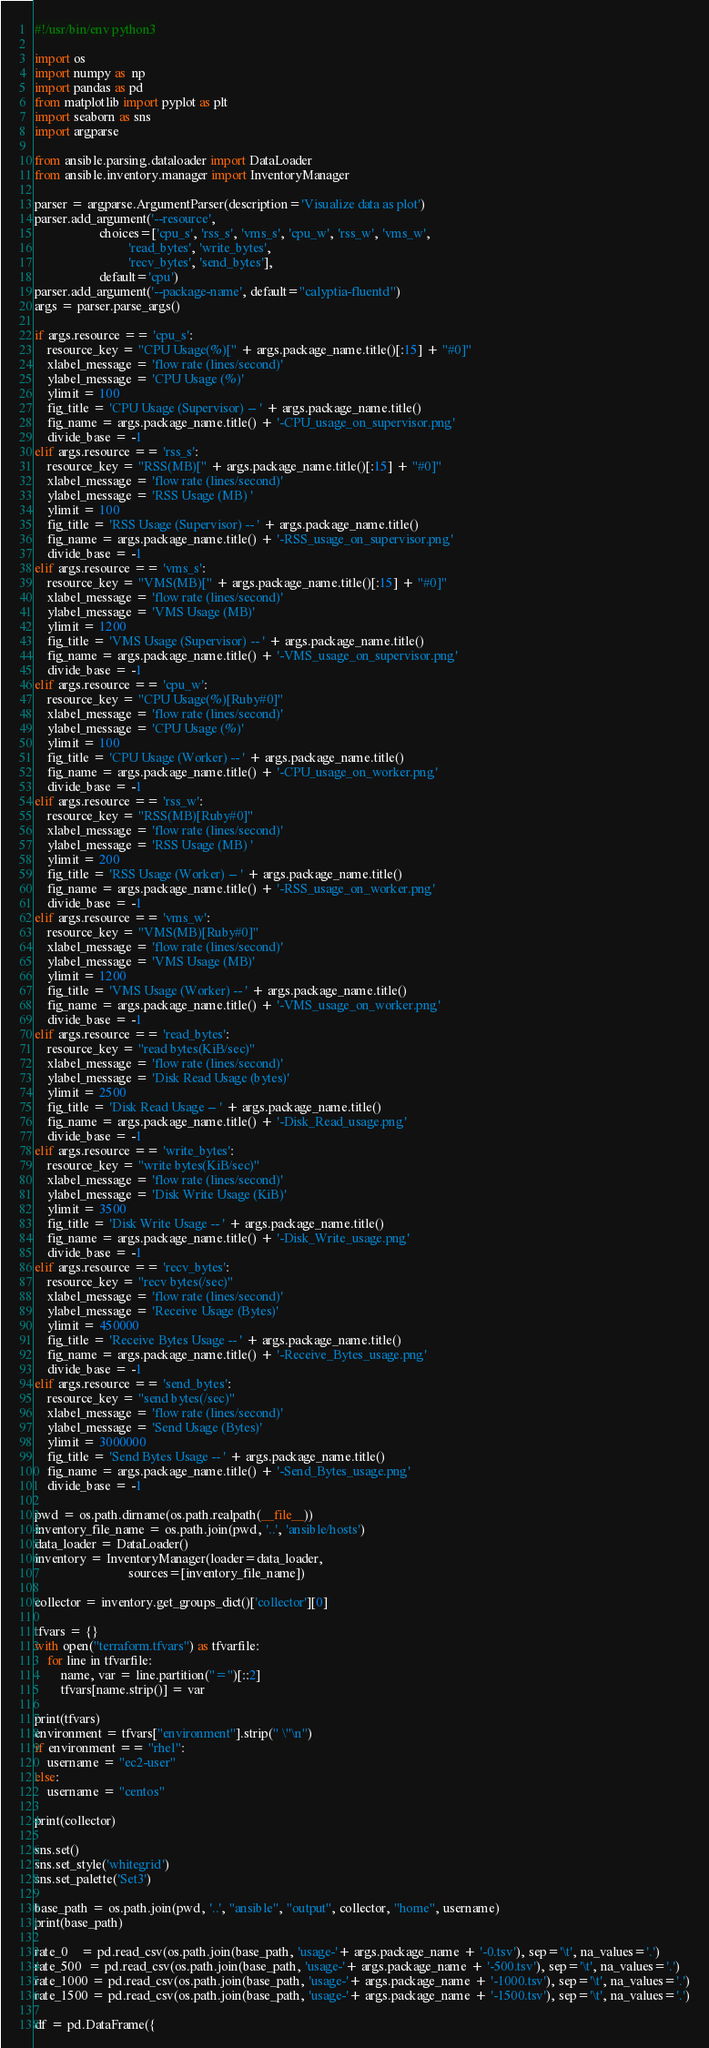<code> <loc_0><loc_0><loc_500><loc_500><_Python_>#!/usr/bin/env python3

import os
import numpy as  np
import pandas as pd
from matplotlib import pyplot as plt
import seaborn as sns
import argparse

from ansible.parsing.dataloader import DataLoader
from ansible.inventory.manager import InventoryManager

parser = argparse.ArgumentParser(description='Visualize data as plot')
parser.add_argument('--resource',
                    choices=['cpu_s', 'rss_s', 'vms_s', 'cpu_w', 'rss_w', 'vms_w',
                             'read_bytes', 'write_bytes',
                             'recv_bytes', 'send_bytes'],
                    default='cpu')
parser.add_argument('--package-name', default="calyptia-fluentd")
args = parser.parse_args()

if args.resource == 'cpu_s':
    resource_key = "CPU Usage(%)[" + args.package_name.title()[:15] + "#0]"
    xlabel_message = 'flow rate (lines/second)'
    ylabel_message = 'CPU Usage (%)'
    ylimit = 100
    fig_title = 'CPU Usage (Supervisor) -- ' + args.package_name.title()
    fig_name = args.package_name.title() + '-CPU_usage_on_supervisor.png'
    divide_base = -1
elif args.resource == 'rss_s':
    resource_key = "RSS(MB)[" + args.package_name.title()[:15] + "#0]"
    xlabel_message = 'flow rate (lines/second)'
    ylabel_message = 'RSS Usage (MB) '
    ylimit = 100
    fig_title = 'RSS Usage (Supervisor) -- ' + args.package_name.title()
    fig_name = args.package_name.title() + '-RSS_usage_on_supervisor.png'
    divide_base = -1
elif args.resource == 'vms_s':
    resource_key = "VMS(MB)[" + args.package_name.title()[:15] + "#0]"
    xlabel_message = 'flow rate (lines/second)'
    ylabel_message = 'VMS Usage (MB)'
    ylimit = 1200
    fig_title = 'VMS Usage (Supervisor) -- ' + args.package_name.title()
    fig_name = args.package_name.title() + '-VMS_usage_on_supervisor.png'
    divide_base = -1
elif args.resource == 'cpu_w':
    resource_key = "CPU Usage(%)[Ruby#0]"
    xlabel_message = 'flow rate (lines/second)'
    ylabel_message = 'CPU Usage (%)'
    ylimit = 100
    fig_title = 'CPU Usage (Worker) -- ' + args.package_name.title()
    fig_name = args.package_name.title() + '-CPU_usage_on_worker.png'
    divide_base = -1
elif args.resource == 'rss_w':
    resource_key = "RSS(MB)[Ruby#0]"
    xlabel_message = 'flow rate (lines/second)'
    ylabel_message = 'RSS Usage (MB) '
    ylimit = 200
    fig_title = 'RSS Usage (Worker) -- ' + args.package_name.title()
    fig_name = args.package_name.title() + '-RSS_usage_on_worker.png'
    divide_base = -1
elif args.resource == 'vms_w':
    resource_key = "VMS(MB)[Ruby#0]"
    xlabel_message = 'flow rate (lines/second)'
    ylabel_message = 'VMS Usage (MB)'
    ylimit = 1200
    fig_title = 'VMS Usage (Worker) -- ' + args.package_name.title()
    fig_name = args.package_name.title() + '-VMS_usage_on_worker.png'
    divide_base = -1
elif args.resource == 'read_bytes':
    resource_key = "read bytes(KiB/sec)"
    xlabel_message = 'flow rate (lines/second)'
    ylabel_message = 'Disk Read Usage (bytes)'
    ylimit = 2500
    fig_title = 'Disk Read Usage -- ' + args.package_name.title()
    fig_name = args.package_name.title() + '-Disk_Read_usage.png'
    divide_base = -1
elif args.resource == 'write_bytes':
    resource_key = "write bytes(KiB/sec)"
    xlabel_message = 'flow rate (lines/second)'
    ylabel_message = 'Disk Write Usage (KiB)'
    ylimit = 3500
    fig_title = 'Disk Write Usage -- ' + args.package_name.title()
    fig_name = args.package_name.title() + '-Disk_Write_usage.png'
    divide_base = -1
elif args.resource == 'recv_bytes':
    resource_key = "recv bytes(/sec)"
    xlabel_message = 'flow rate (lines/second)'
    ylabel_message = 'Receive Usage (Bytes)'
    ylimit = 450000
    fig_title = 'Receive Bytes Usage -- ' + args.package_name.title()
    fig_name = args.package_name.title() + '-Receive_Bytes_usage.png'
    divide_base = -1
elif args.resource == 'send_bytes':
    resource_key = "send bytes(/sec)"
    xlabel_message = 'flow rate (lines/second)'
    ylabel_message = 'Send Usage (Bytes)'
    ylimit = 3000000
    fig_title = 'Send Bytes Usage -- ' + args.package_name.title()
    fig_name = args.package_name.title() + '-Send_Bytes_usage.png'
    divide_base = -1

pwd = os.path.dirname(os.path.realpath(__file__))
inventory_file_name = os.path.join(pwd, '..', 'ansible/hosts')
data_loader = DataLoader()
inventory = InventoryManager(loader=data_loader,
                             sources=[inventory_file_name])

collector = inventory.get_groups_dict()['collector'][0]

tfvars = {}
with open("terraform.tfvars") as tfvarfile:
    for line in tfvarfile:
        name, var = line.partition("=")[::2]
        tfvars[name.strip()] = var

print(tfvars)
environment = tfvars["environment"].strip(" \"\n")
if environment == "rhel":
    username = "ec2-user"
else:
    username = "centos"

print(collector)

sns.set()
sns.set_style('whitegrid')
sns.set_palette('Set3')

base_path = os.path.join(pwd, '..', "ansible", "output", collector, "home", username)
print(base_path)

rate_0    = pd.read_csv(os.path.join(base_path, 'usage-'+ args.package_name + '-0.tsv'), sep='\t', na_values='.')
rate_500  = pd.read_csv(os.path.join(base_path, 'usage-'+ args.package_name + '-500.tsv'), sep='\t', na_values='.')
rate_1000 = pd.read_csv(os.path.join(base_path, 'usage-'+ args.package_name + '-1000.tsv'), sep='\t', na_values='.')
rate_1500 = pd.read_csv(os.path.join(base_path, 'usage-'+ args.package_name + '-1500.tsv'), sep='\t', na_values='.')

df = pd.DataFrame({</code> 